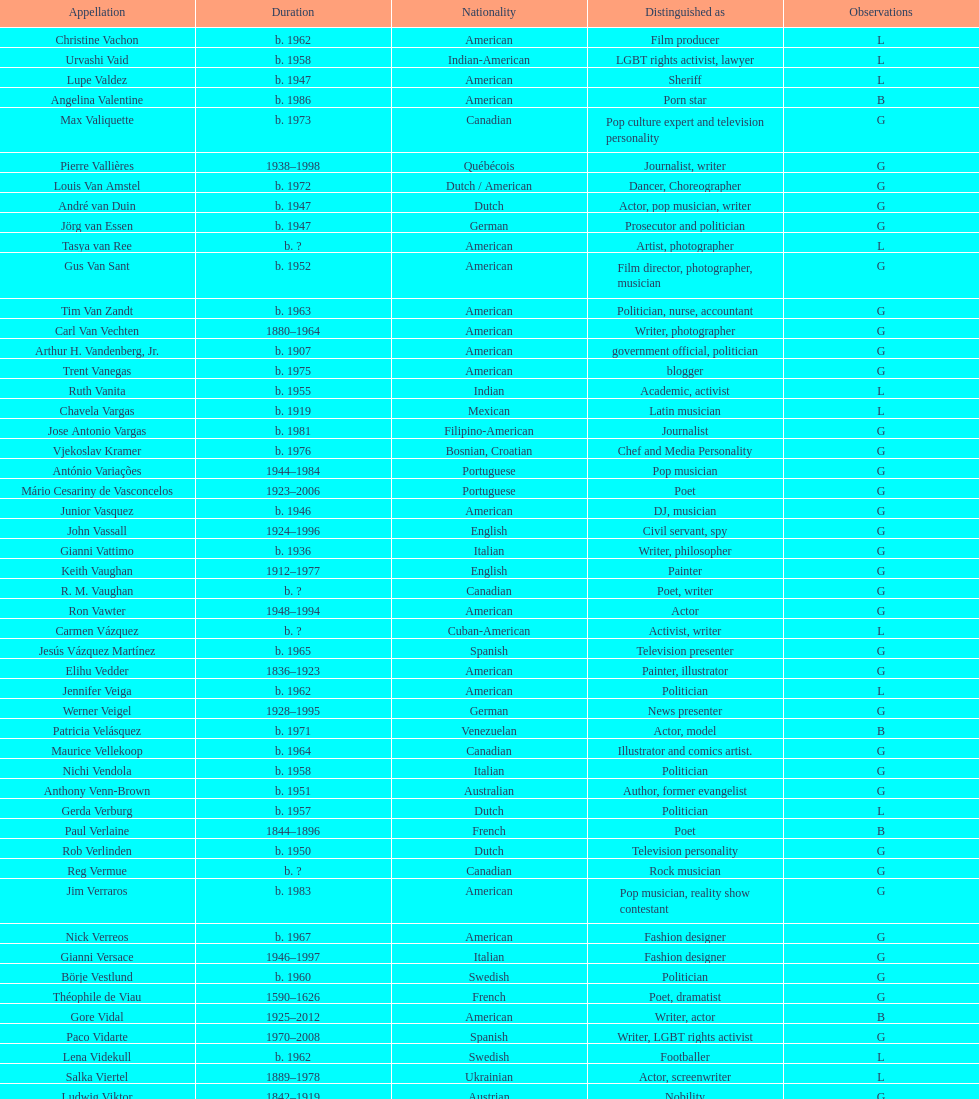How old was pierre vallieres before he died? 60. 